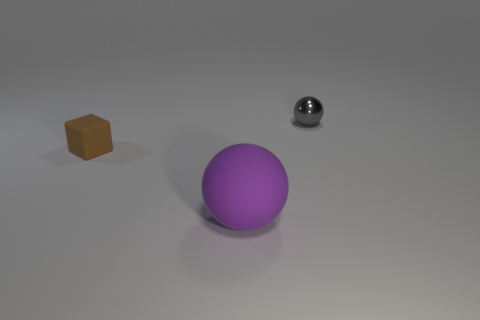Is there anything else that has the same size as the purple ball?
Give a very brief answer. No. Are there any other blocks that have the same size as the block?
Provide a short and direct response. No. There is a rubber object that is behind the big thing; is its shape the same as the small metallic thing?
Provide a succinct answer. No. What is the color of the tiny metallic ball?
Give a very brief answer. Gray. Is there a big yellow sphere?
Provide a short and direct response. No. There is a brown block that is the same material as the purple ball; what is its size?
Keep it short and to the point. Small. There is a tiny thing on the left side of the ball behind the ball on the left side of the gray metal thing; what is its shape?
Offer a terse response. Cube. Is the number of purple balls that are on the right side of the large object the same as the number of big purple objects?
Provide a short and direct response. No. Do the large purple object and the gray metal object have the same shape?
Keep it short and to the point. Yes. How many objects are either small objects that are in front of the gray thing or purple matte spheres?
Your answer should be very brief. 2. 